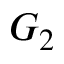<formula> <loc_0><loc_0><loc_500><loc_500>G _ { 2 }</formula> 